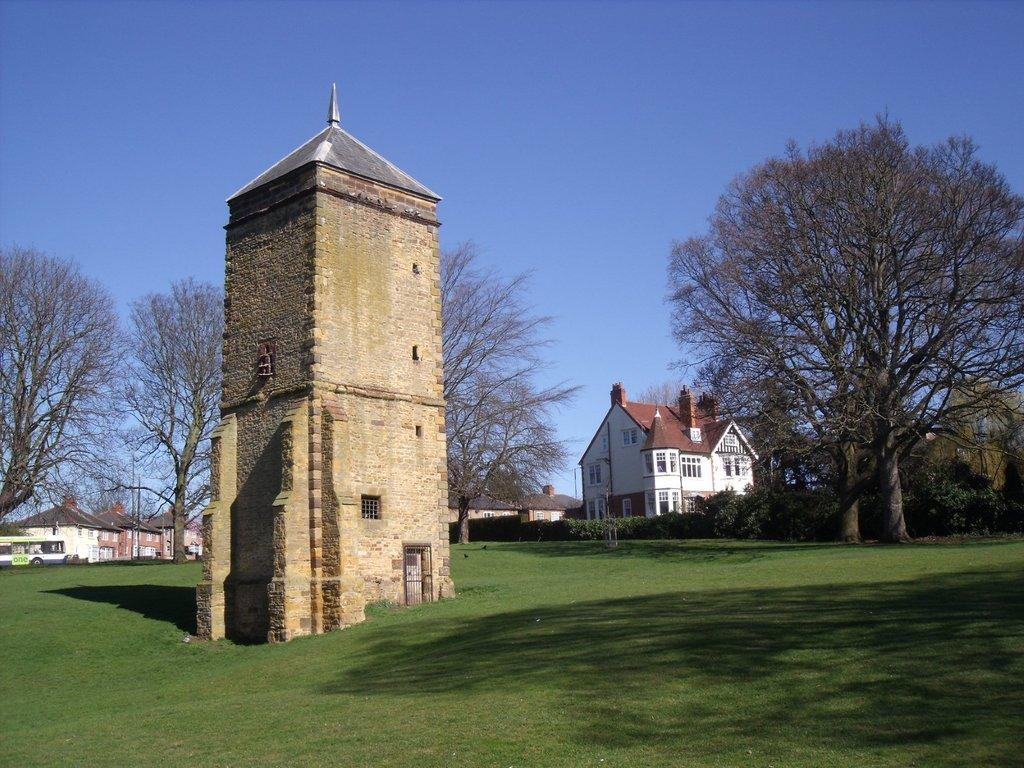What type of structures can be seen in the image? There are buildings in the image. What is happening on the road in the image? A vehicle is moving on the road in the image. What type of vegetation is present in the image? There are trees and grass in the image. Can you describe the surface of the grass? The surface of the grass is visible in the image. What can be seen in the background of the image? The sky is visible in the background of the image. What type of haircut is the road receiving in the image? There is no haircut being given in the image, as the subject is a moving vehicle on the road. What color is the sky in the image? The provided facts do not mention the color of the sky, only that it is visible in the background. 